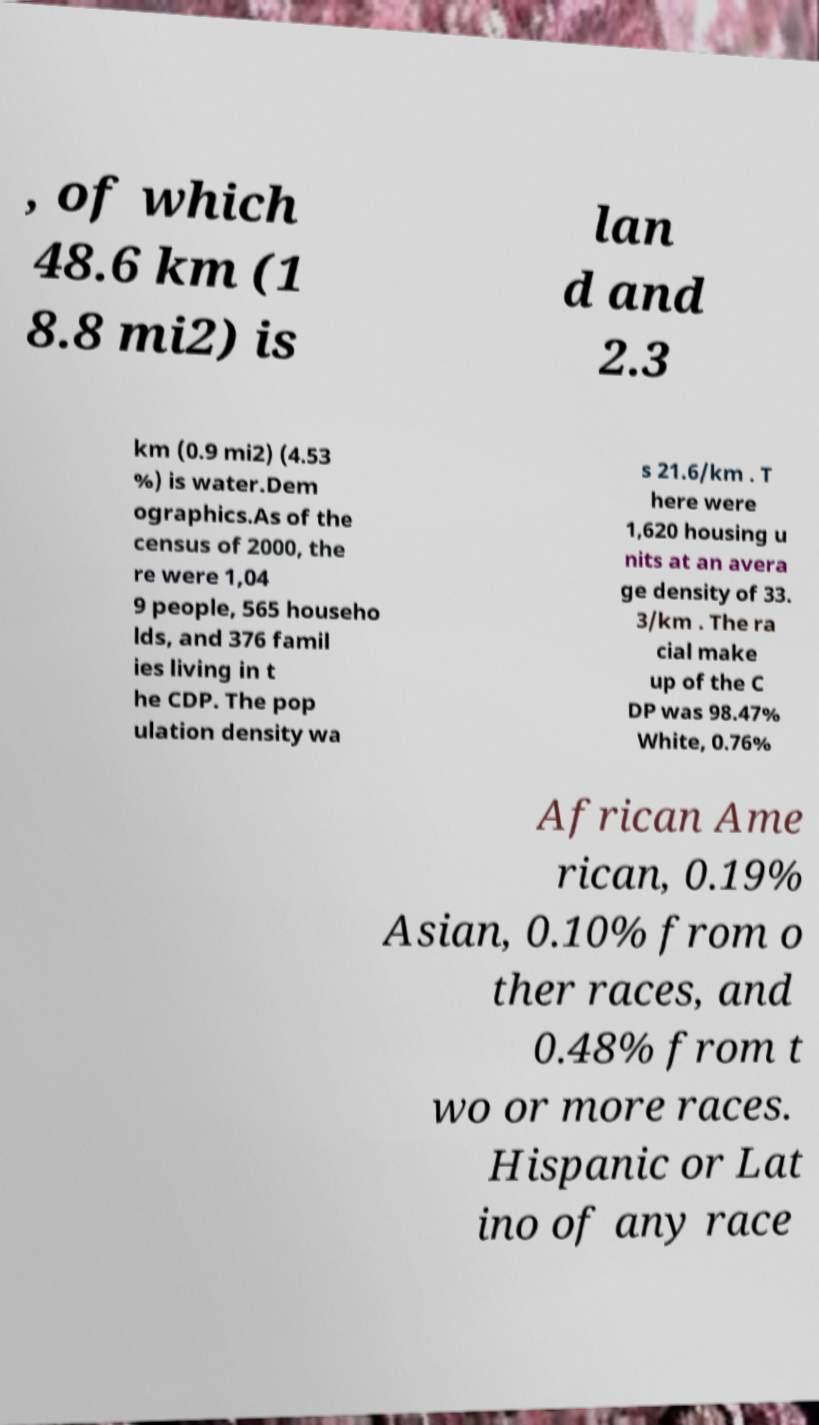For documentation purposes, I need the text within this image transcribed. Could you provide that? , of which 48.6 km (1 8.8 mi2) is lan d and 2.3 km (0.9 mi2) (4.53 %) is water.Dem ographics.As of the census of 2000, the re were 1,04 9 people, 565 househo lds, and 376 famil ies living in t he CDP. The pop ulation density wa s 21.6/km . T here were 1,620 housing u nits at an avera ge density of 33. 3/km . The ra cial make up of the C DP was 98.47% White, 0.76% African Ame rican, 0.19% Asian, 0.10% from o ther races, and 0.48% from t wo or more races. Hispanic or Lat ino of any race 